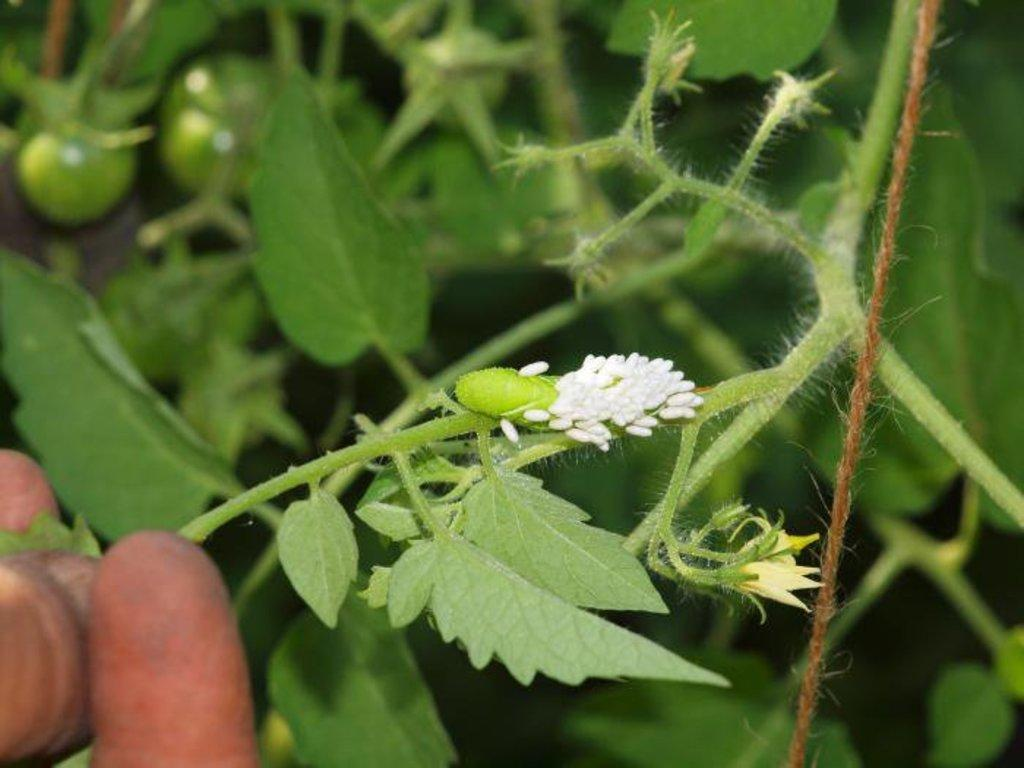What type of living organism can be seen in the image? There is a plant in the image. What object is also visible in the image? There is a rope in the image. Can you describe the background of the image? The background of the image is blurred. How many shoes can be seen hanging from the plant in the image? There are no shoes present in the image; it features a plant and a rope. What type of clover is growing near the plant in the image? There is no clover present in the image. 